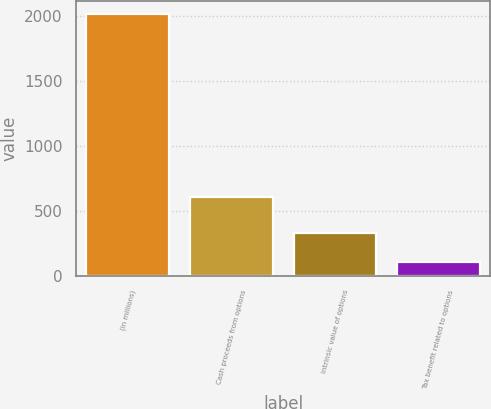<chart> <loc_0><loc_0><loc_500><loc_500><bar_chart><fcel>(in millions)<fcel>Cash proceeds from options<fcel>Intrinsic value of options<fcel>Tax benefit related to options<nl><fcel>2015<fcel>609<fcel>329<fcel>106<nl></chart> 